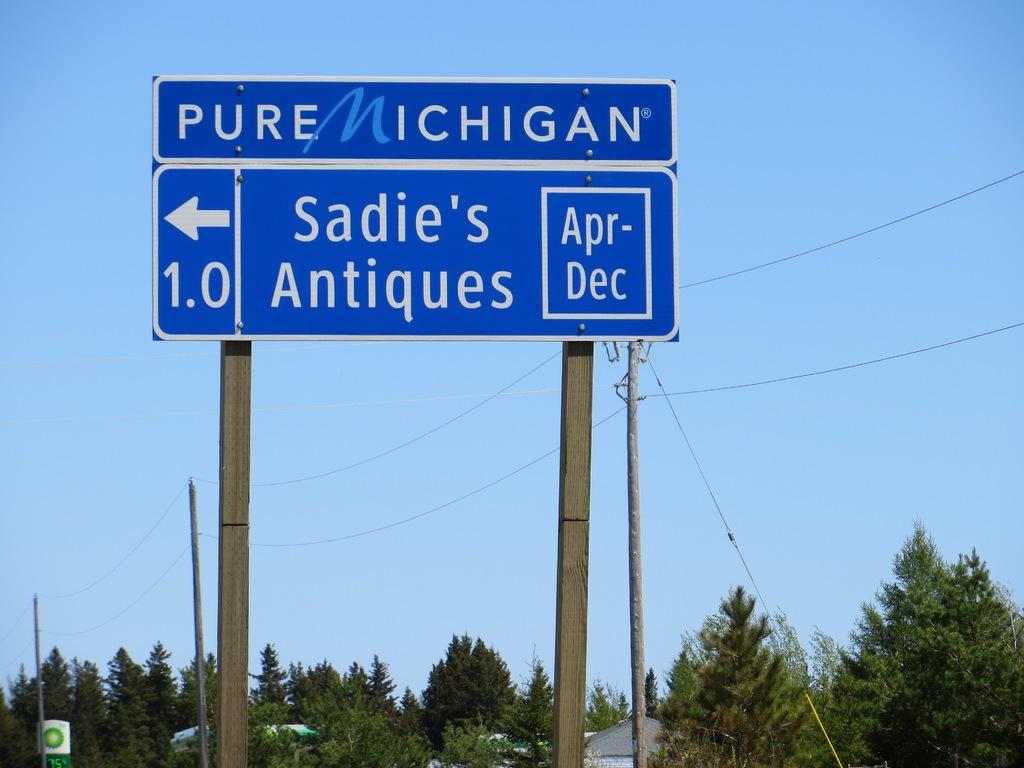<image>
Share a concise interpretation of the image provided. A Michigan road sign points the way to Sadie's Antiques. 